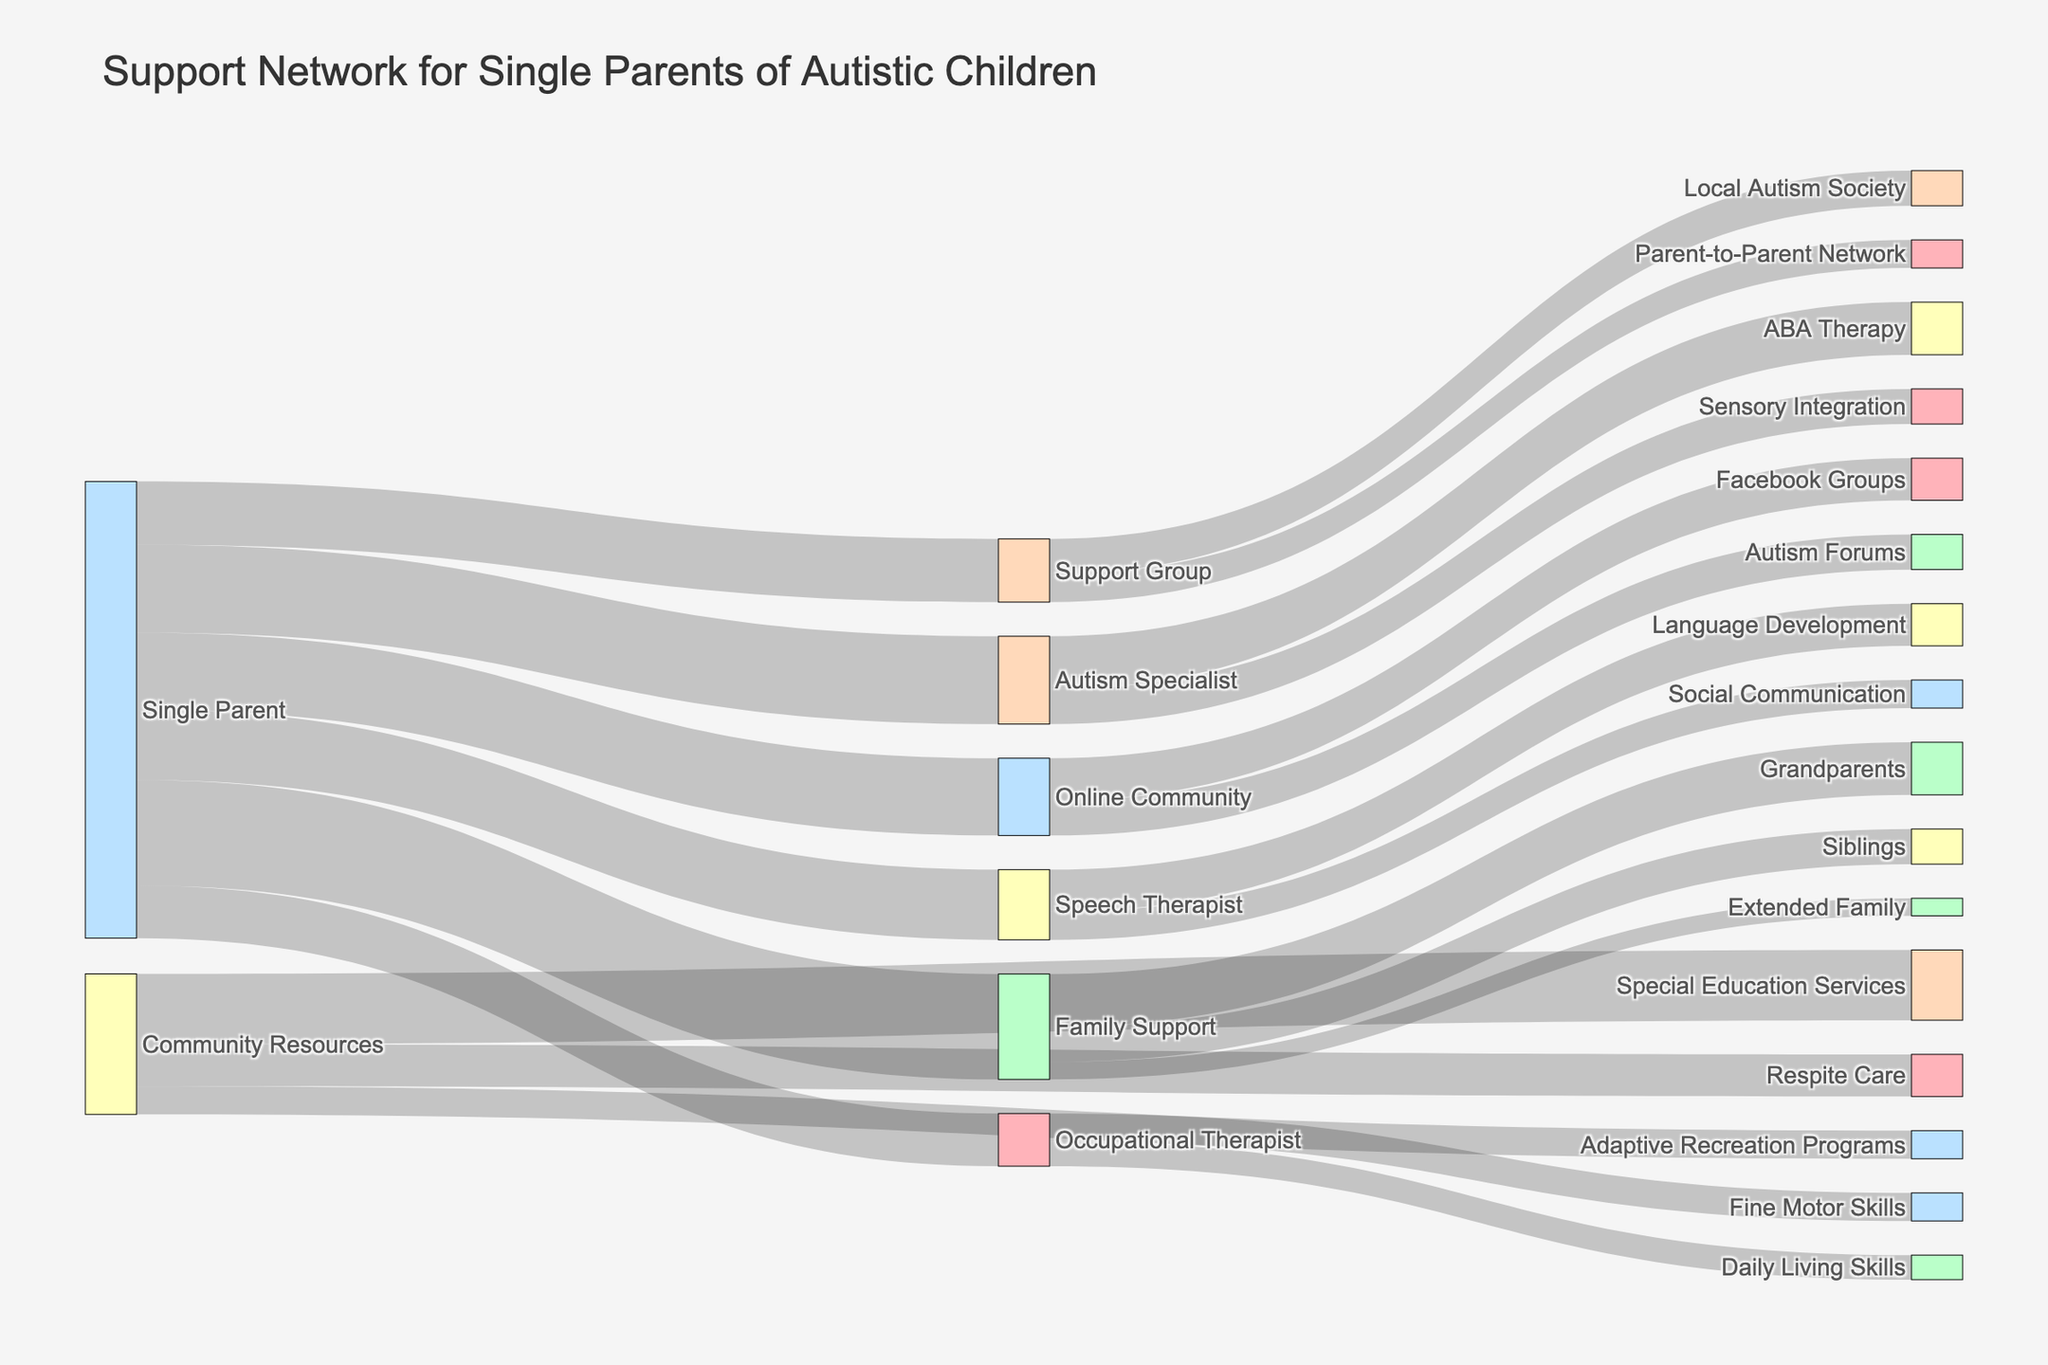Which source has the highest value directed towards it? By examining the Sankey Diagram, you can see which node originating from the "Single Parent" node has the highest numerical value linked to it.
Answer: Family Support What is the total value of support received from the Family Support node? To find this, add the values of "Grandparents", "Siblings", and "Extended Family" emanating from the "Family Support" node: 15 + 10 + 5
Answer: 30 How does the value of the Autism Specialist node compare to the Support Group node? Compare the sum of values leading to each node from "Single Parent." Autism Specialist has 25, while Support Group has 18.
Answer: Autism Specialist has a higher value Which community resource has the highest value? Looking at the nodes originating from "Community Resources," compare the values of "Respite Care", "Special Education Services", and "Adaptive Recreation Programs."
Answer: Special Education Services Which professional provides the most diverse range of services? Identify the node with the most outgoing connections. Compare "Autism Specialist", "Speech Therapist", and "Occupational Therapist."
Answer: Autism Specialist What is the combined value of services provided by Speech Therapist and Occupational Therapist? Add up all values associated with these nodes: 12 + 8 + 8 + 7
Answer: 35 Is there a significant difference in values between Online Community and Support Group? Compare the total values for "Online Community" (22) and "Support Group" (18).
Answer: Yes, Online Community has a higher value What portion of the Family Support value comes from Grandparents? Compute the proportion: 15 (value from Grandparents) / 30 (total Family Support value)
Answer: 50% What's the relationship between Single Parent and ABA Therapy? Trace the flow from "Single Parent" to "Autism Specialist" and then to "ABA Therapy." The value is 15 through these connections.
Answer: 15 